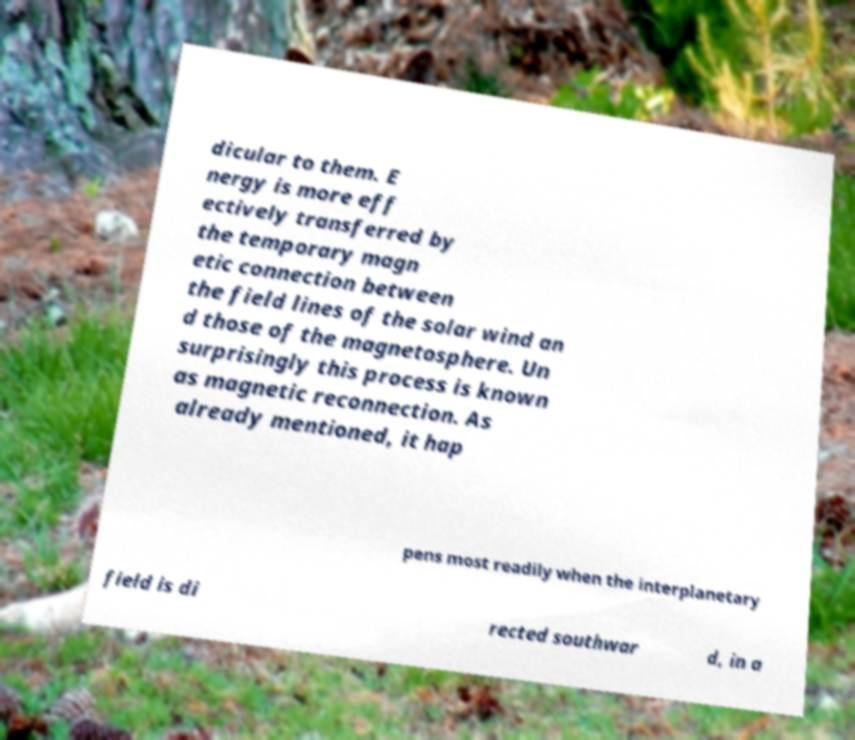For documentation purposes, I need the text within this image transcribed. Could you provide that? dicular to them. E nergy is more eff ectively transferred by the temporary magn etic connection between the field lines of the solar wind an d those of the magnetosphere. Un surprisingly this process is known as magnetic reconnection. As already mentioned, it hap pens most readily when the interplanetary field is di rected southwar d, in a 